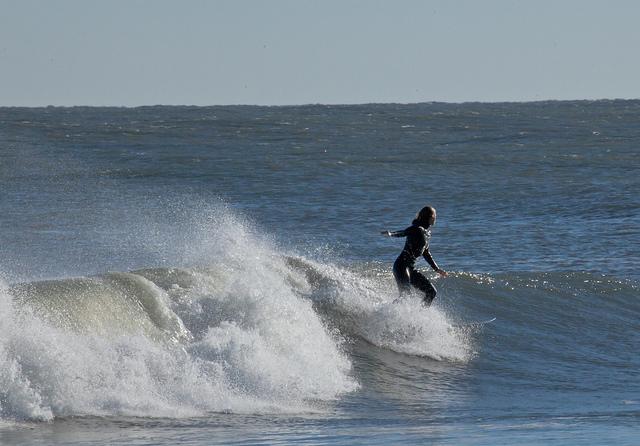Is this a beach?
Write a very short answer. Yes. Is there a boat somewhere near?
Quick response, please. No. Is it a cloudy day?
Short answer required. No. Is the wave taller than the person?
Write a very short answer. No. What is the person doing in the water?
Quick response, please. Surfing. 